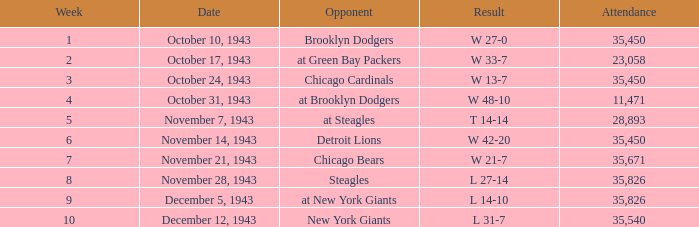How many instances have a result of w 48-10 in terms of attendance? 11471.0. 